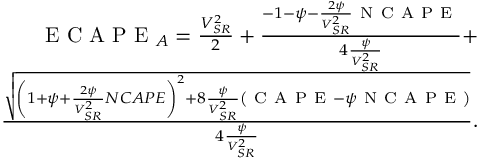Convert formula to latex. <formula><loc_0><loc_0><loc_500><loc_500>\begin{array} { r } { E C A P E _ { A } = \frac { V _ { S R } ^ { 2 } } { 2 } + \frac { - 1 - \psi - \frac { 2 \psi } { V _ { S R } ^ { 2 } } N C A P E } { 4 \frac { \psi } { V _ { S R } ^ { 2 } } } + } \\ { \frac { \sqrt { \left ( 1 + \psi + \frac { 2 \psi } { V _ { S R } ^ { 2 } } N C A P E \right ) ^ { 2 } + 8 \frac { \psi } { V _ { S R } ^ { 2 } } \left ( C A P E - \psi N C A P E \right ) } } { 4 \frac { \psi } { V _ { S R } ^ { 2 } } } . } \end{array}</formula> 